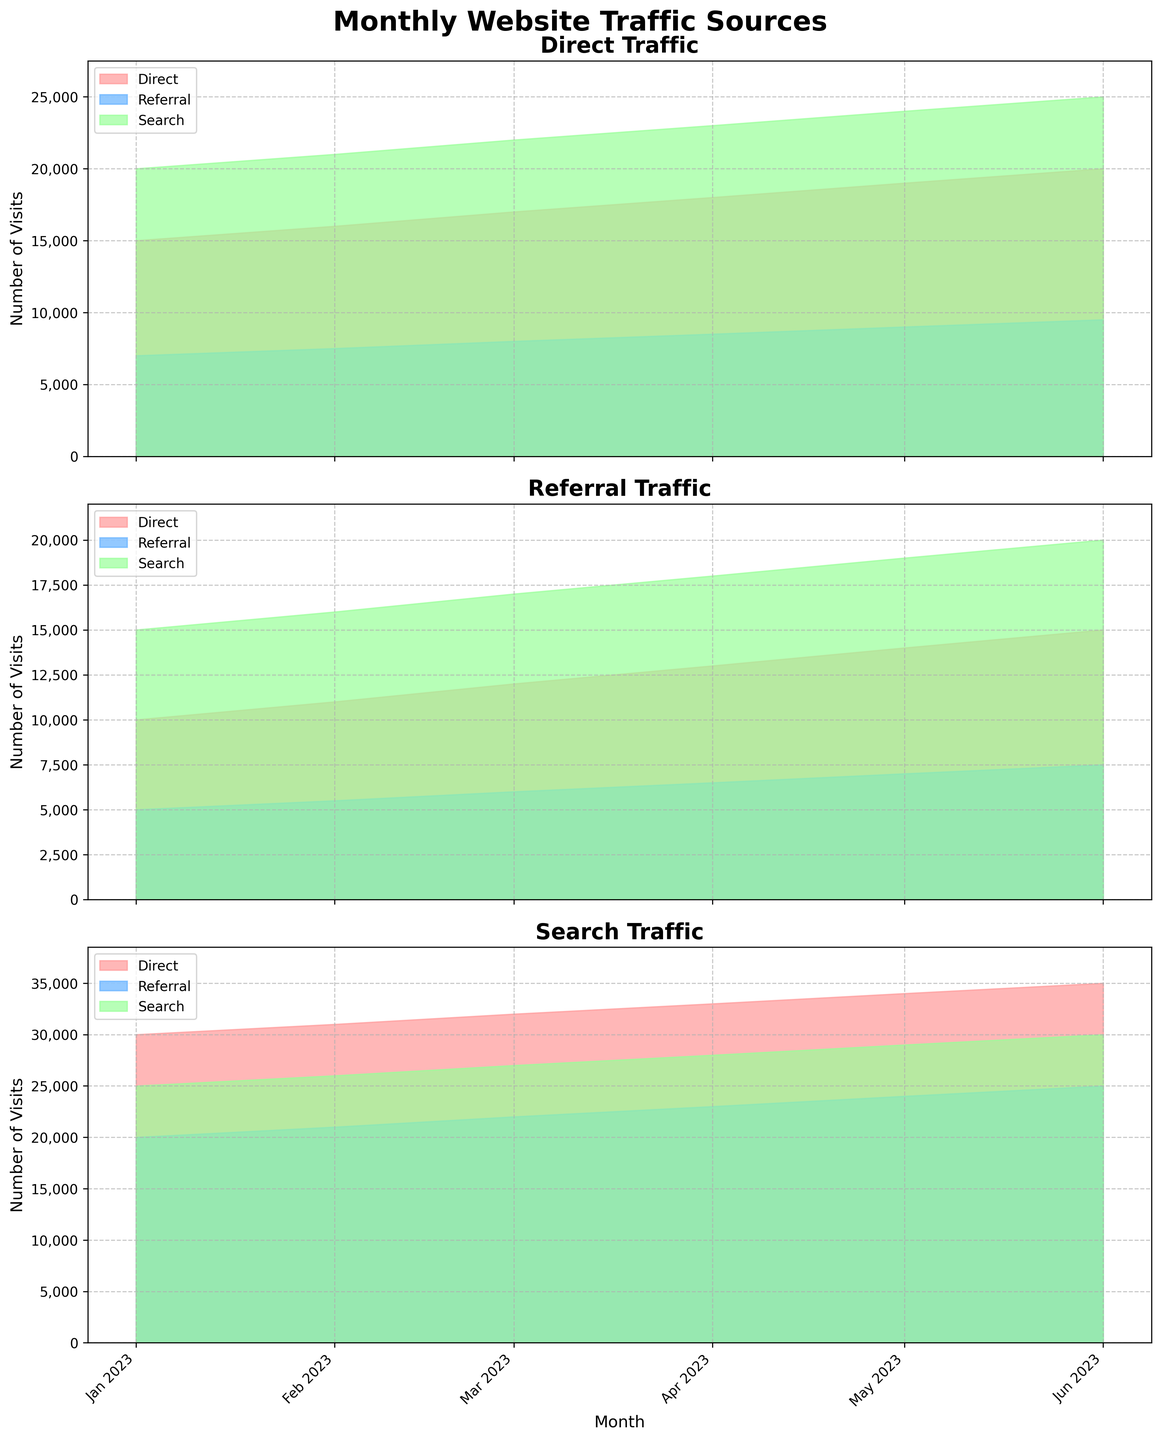What's the title of the figure? The title is displayed at the very top of the figure in large, bold font.
Answer: Monthly Website Traffic Sources How does the number of visits change over time for Direct Traffic? By examining the filled areas for Direct visits in each subplot, it shows a general increasing trend over the months from January to June.
Answer: Increasing Which month had the highest overall Search Traffic? By observing the filled areas for Search traffic in the Search Traffic subplot, the highest peak is in June 2023.
Answer: June 2023 Compare the Referral Traffic in March and April. Which month had more visits? Look at the filled areas for Referral traffic in the Referral Traffic subplot. The height of the area in April is slightly higher than in March.
Answer: April What is the difference in Direct Traffic visits between January and June? Subtract the number of visits in January (15,000) from the number of visits in June (20,000): \(20,000 - 15,000 = 5,000\).
Answer: 5,000 What's the combined total of Referral Traffic in May for all sources? Add up Referral visits in May for Direct (9000), Referral (7000), and Search (24000): \(9,000 + 7,000 + 24,000 = 40,000\).
Answer: 40,000 Which traffic source appears to have the most consistent (stable) growth? Examine the slopes of the filled areas across subplots; Search Traffic shows a steady increase without large fluctuations.
Answer: Search Traffic Is there any month where Referral Traffic surpassed Direct Traffic for any traffic source? In each subplot, compare the area heights for Referral and Direct traffic month-by-month. In no month does Referral surpass Direct for any source.
Answer: No How does the Referral Traffic compare to the Search Traffic in May for the Referral traffic source? For May in the Referral traffic subplot, Referral is less than Search (7,000 vs 19,000).
Answer: Less What is the trend for Search Traffic from January to June? The filled areas for Search Traffic in the Search Traffic subplot show a constant increase every month.
Answer: Increasing Which traffic source shows the highest variability in visits from month to month? By comparing fluctuations in areas (changes in height), Referral Traffic shows more variability than Direct or Search across all months.
Answer: Referral Traffic 